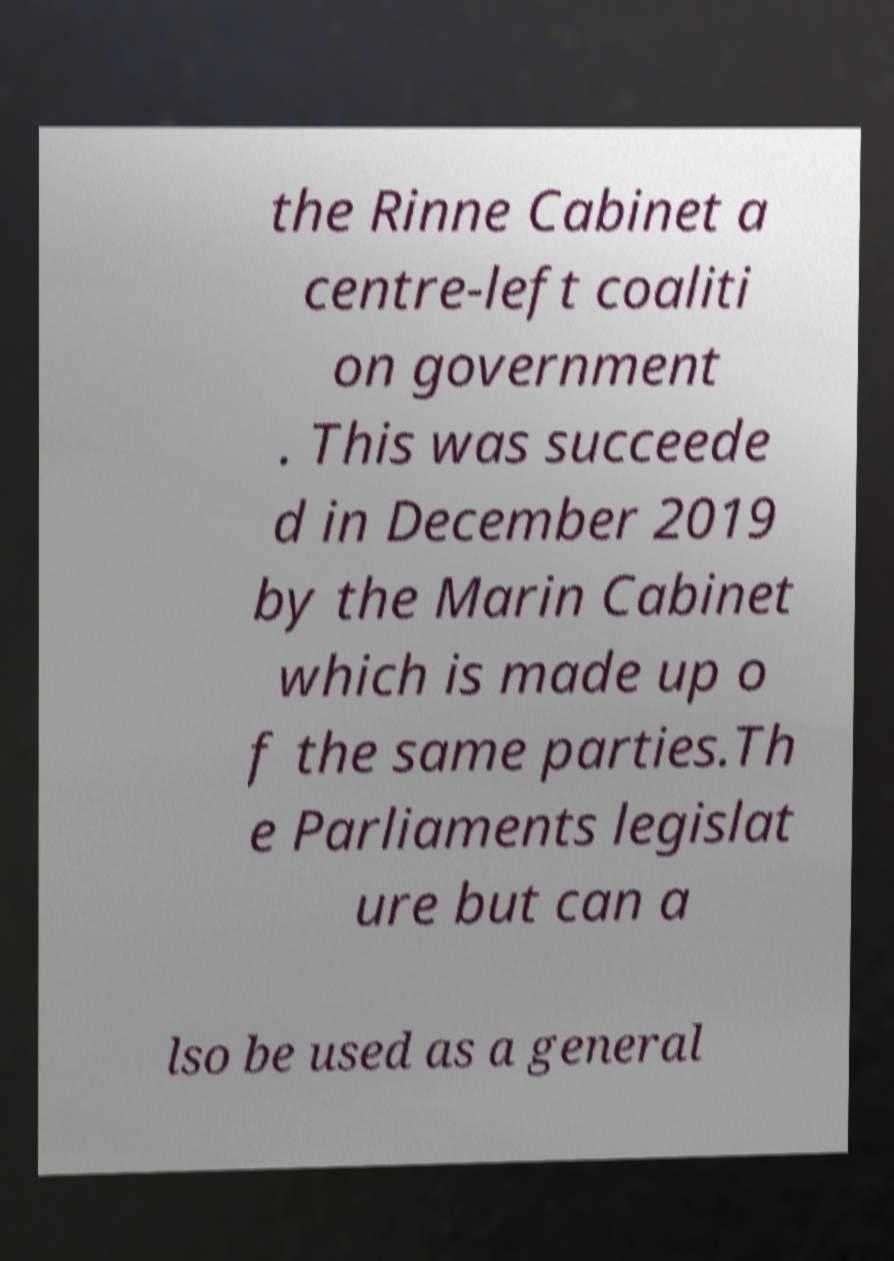For documentation purposes, I need the text within this image transcribed. Could you provide that? the Rinne Cabinet a centre-left coaliti on government . This was succeede d in December 2019 by the Marin Cabinet which is made up o f the same parties.Th e Parliaments legislat ure but can a lso be used as a general 